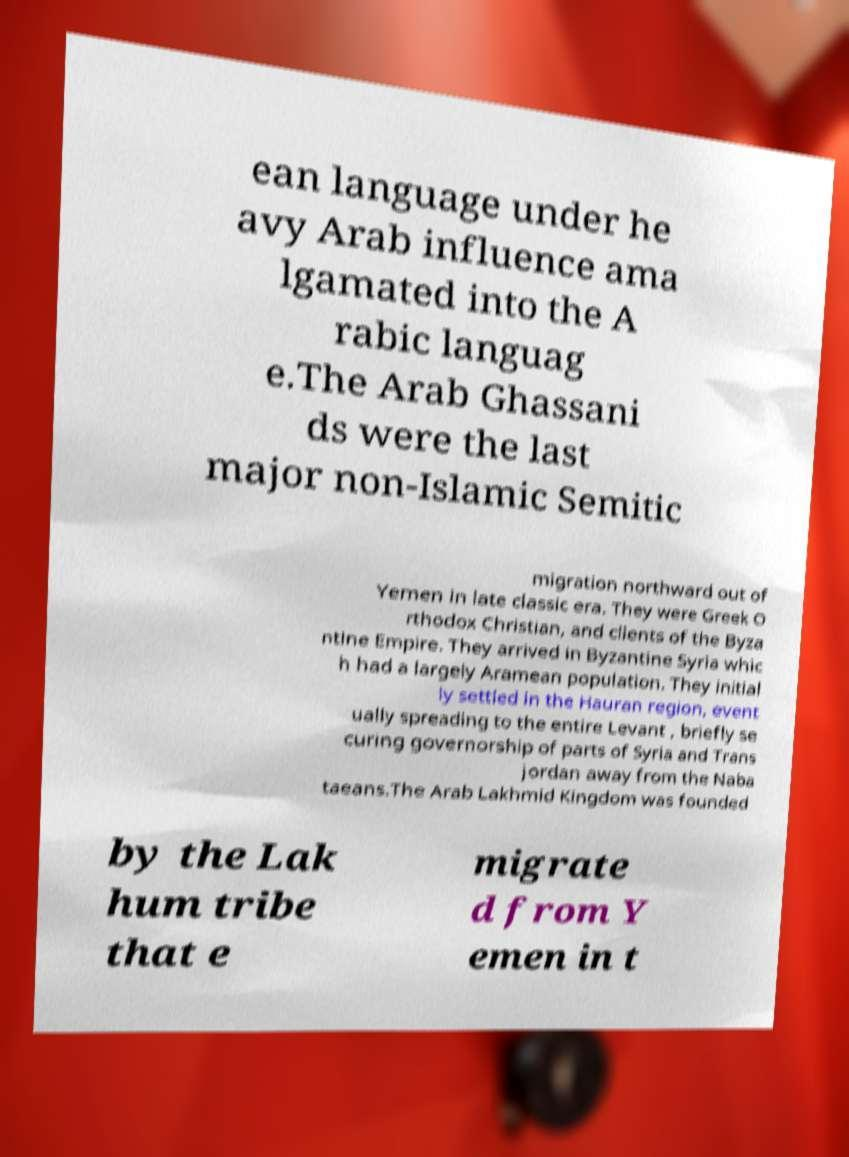There's text embedded in this image that I need extracted. Can you transcribe it verbatim? ean language under he avy Arab influence ama lgamated into the A rabic languag e.The Arab Ghassani ds were the last major non-Islamic Semitic migration northward out of Yemen in late classic era. They were Greek O rthodox Christian, and clients of the Byza ntine Empire. They arrived in Byzantine Syria whic h had a largely Aramean population. They initial ly settled in the Hauran region, event ually spreading to the entire Levant , briefly se curing governorship of parts of Syria and Trans jordan away from the Naba taeans.The Arab Lakhmid Kingdom was founded by the Lak hum tribe that e migrate d from Y emen in t 